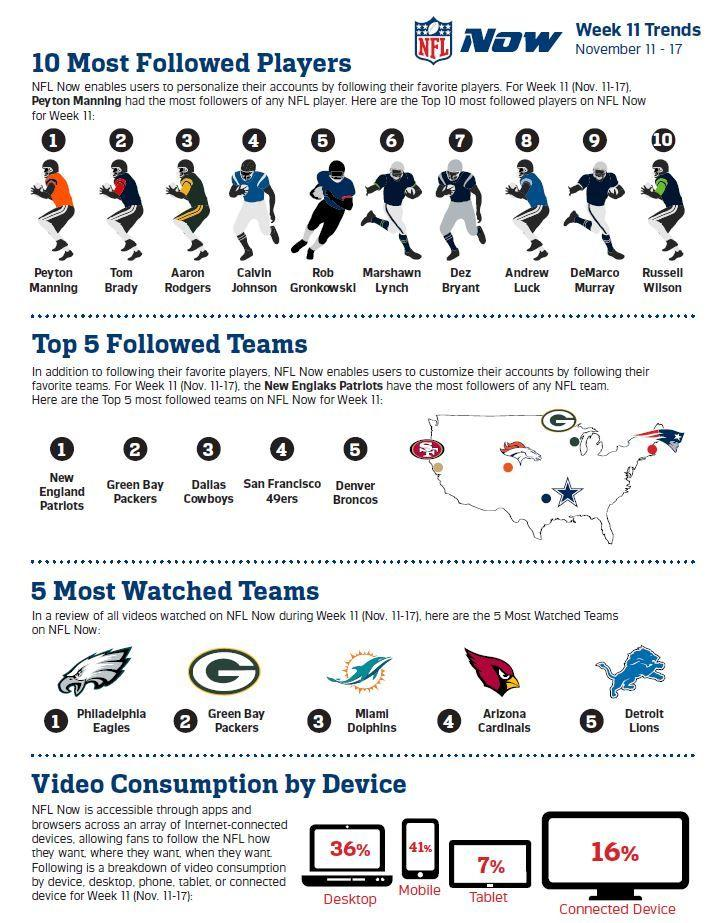Mention a couple of crucial points in this snapshot. The headquarters of the San Francisco 49ers is located in Santa Clara, Colorado, or Boston. The player ranked 7th is three places right of the player ranked 4th, and that player is Russel Wilson. The player who is placed two positions to the left of the sixth-ranked player is Calvin Johnson. According to the given options, approximately 16% of viewers use connected devices to follow the NFL, which is less than the other options presented. According to data, mobile devices are the most commonly used to access the NFL. 